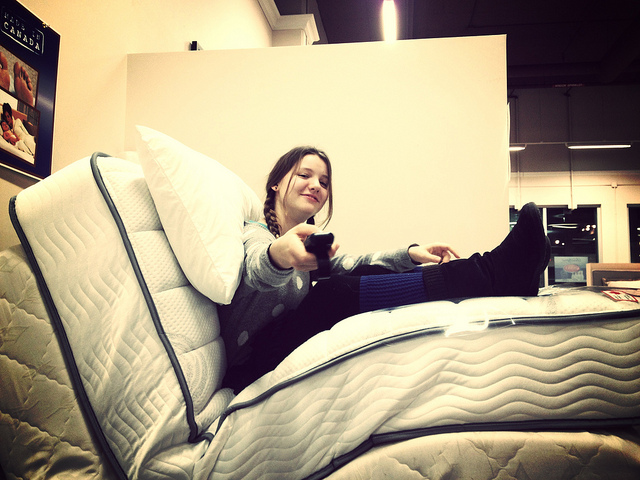Please extract the text content from this image. CAN CANADA 